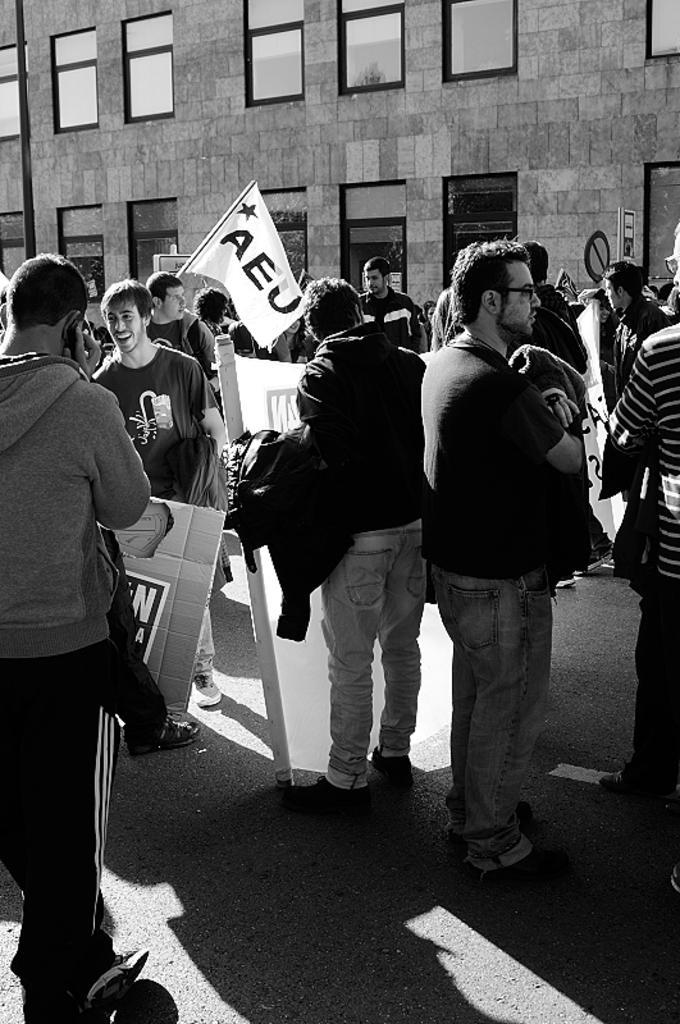How would you summarize this image in a sentence or two? In this image I can see the black and white picture in which I can see few persons are standing and holding flags and boards in their hands. In the background I can see a building and few windows of the building. 